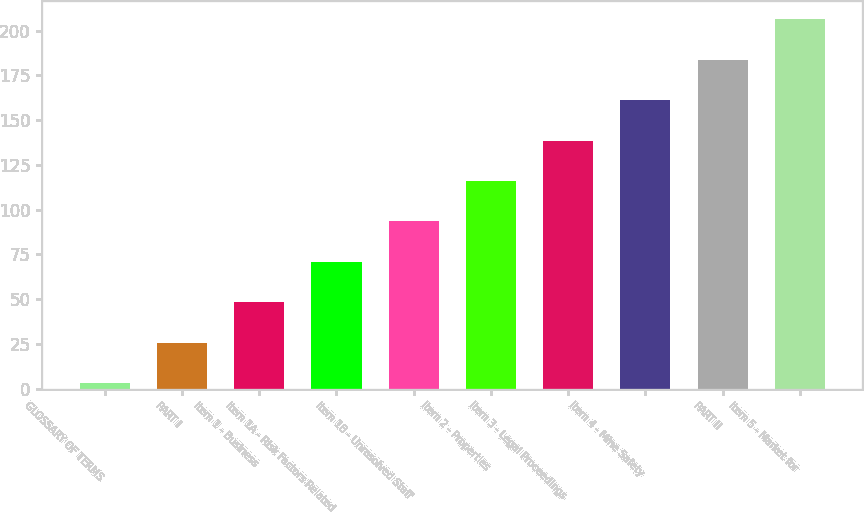<chart> <loc_0><loc_0><loc_500><loc_500><bar_chart><fcel>GLOSSARY OF TERMS<fcel>PART I<fcel>Item 1 - Business<fcel>Item 1A - Risk Factors Related<fcel>Item 1B - Unresolved Staff<fcel>Item 2 - Properties<fcel>Item 3 - Legal Proceedings<fcel>Item 4 - Mine Safety<fcel>PART II<fcel>Item 5 - Market for<nl><fcel>3<fcel>25.6<fcel>48.2<fcel>70.8<fcel>93.4<fcel>116<fcel>138.6<fcel>161.2<fcel>183.8<fcel>206.4<nl></chart> 